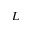<formula> <loc_0><loc_0><loc_500><loc_500>L</formula> 